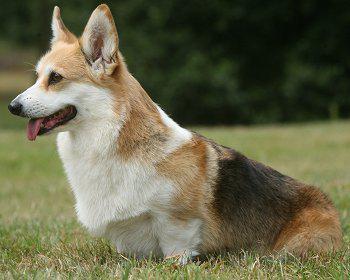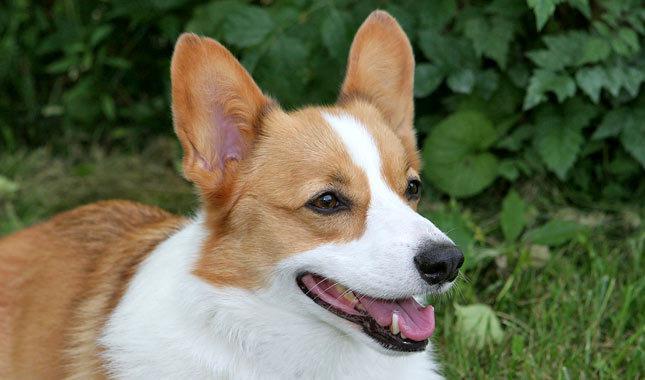The first image is the image on the left, the second image is the image on the right. Analyze the images presented: Is the assertion "Left image shows a corgi dog standing with body turned rightward." valid? Answer yes or no. No. The first image is the image on the left, the second image is the image on the right. Evaluate the accuracy of this statement regarding the images: "The dog in the image on the left is facing right". Is it true? Answer yes or no. No. 